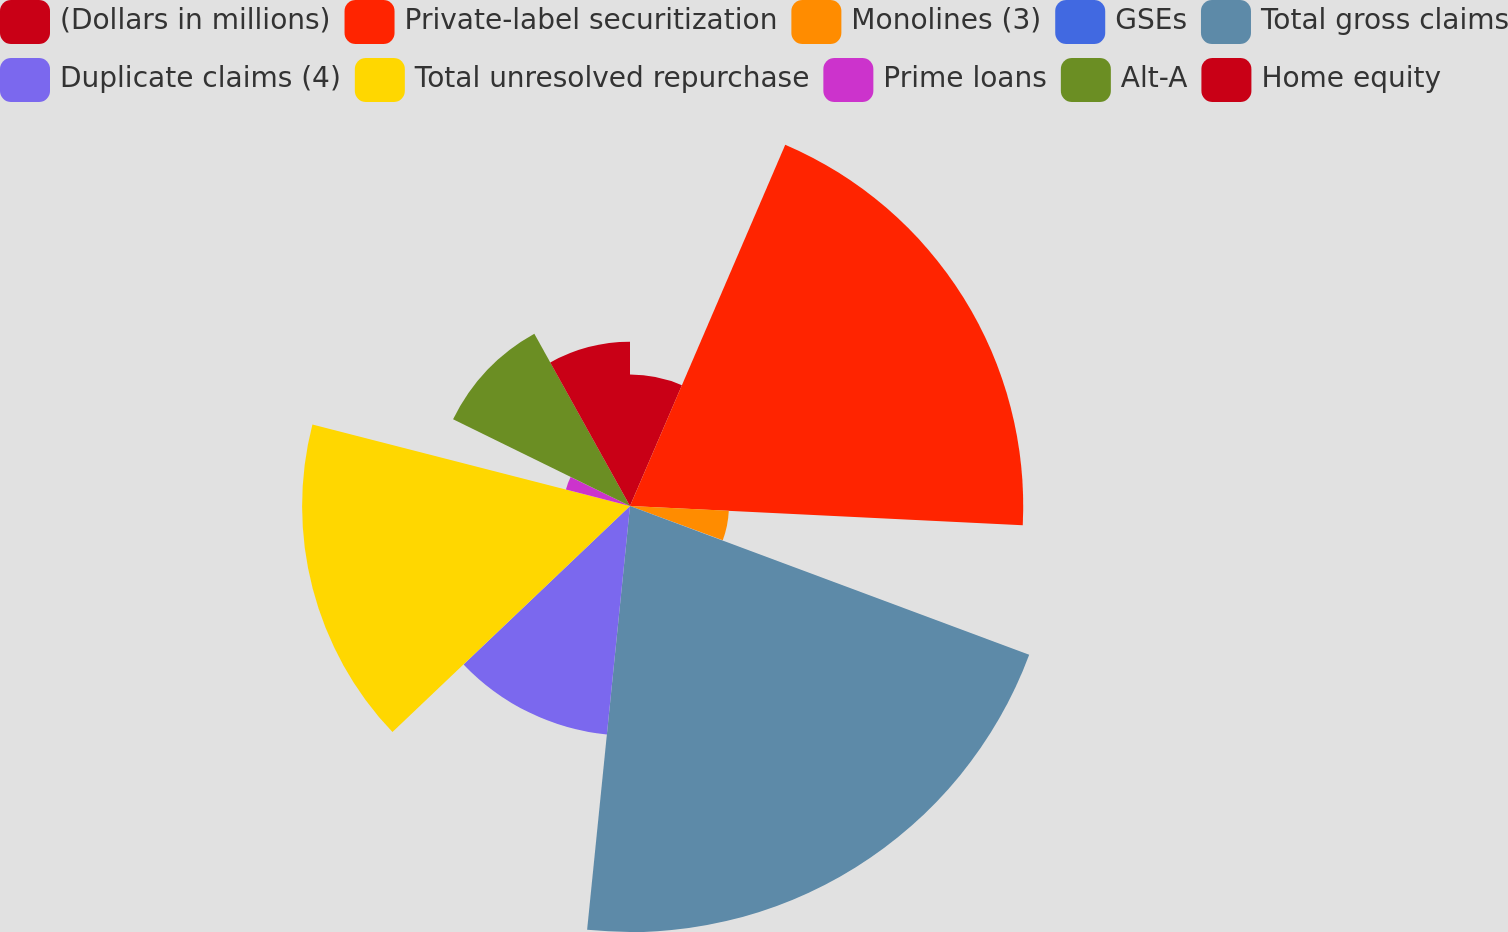Convert chart to OTSL. <chart><loc_0><loc_0><loc_500><loc_500><pie_chart><fcel>(Dollars in millions)<fcel>Private-label securitization<fcel>Monolines (3)<fcel>GSEs<fcel>Total gross claims<fcel>Duplicate claims (4)<fcel>Total unresolved repurchase<fcel>Prime loans<fcel>Alt-A<fcel>Home equity<nl><fcel>6.46%<fcel>19.32%<fcel>4.86%<fcel>0.04%<fcel>20.93%<fcel>11.29%<fcel>16.11%<fcel>3.25%<fcel>9.68%<fcel>8.07%<nl></chart> 